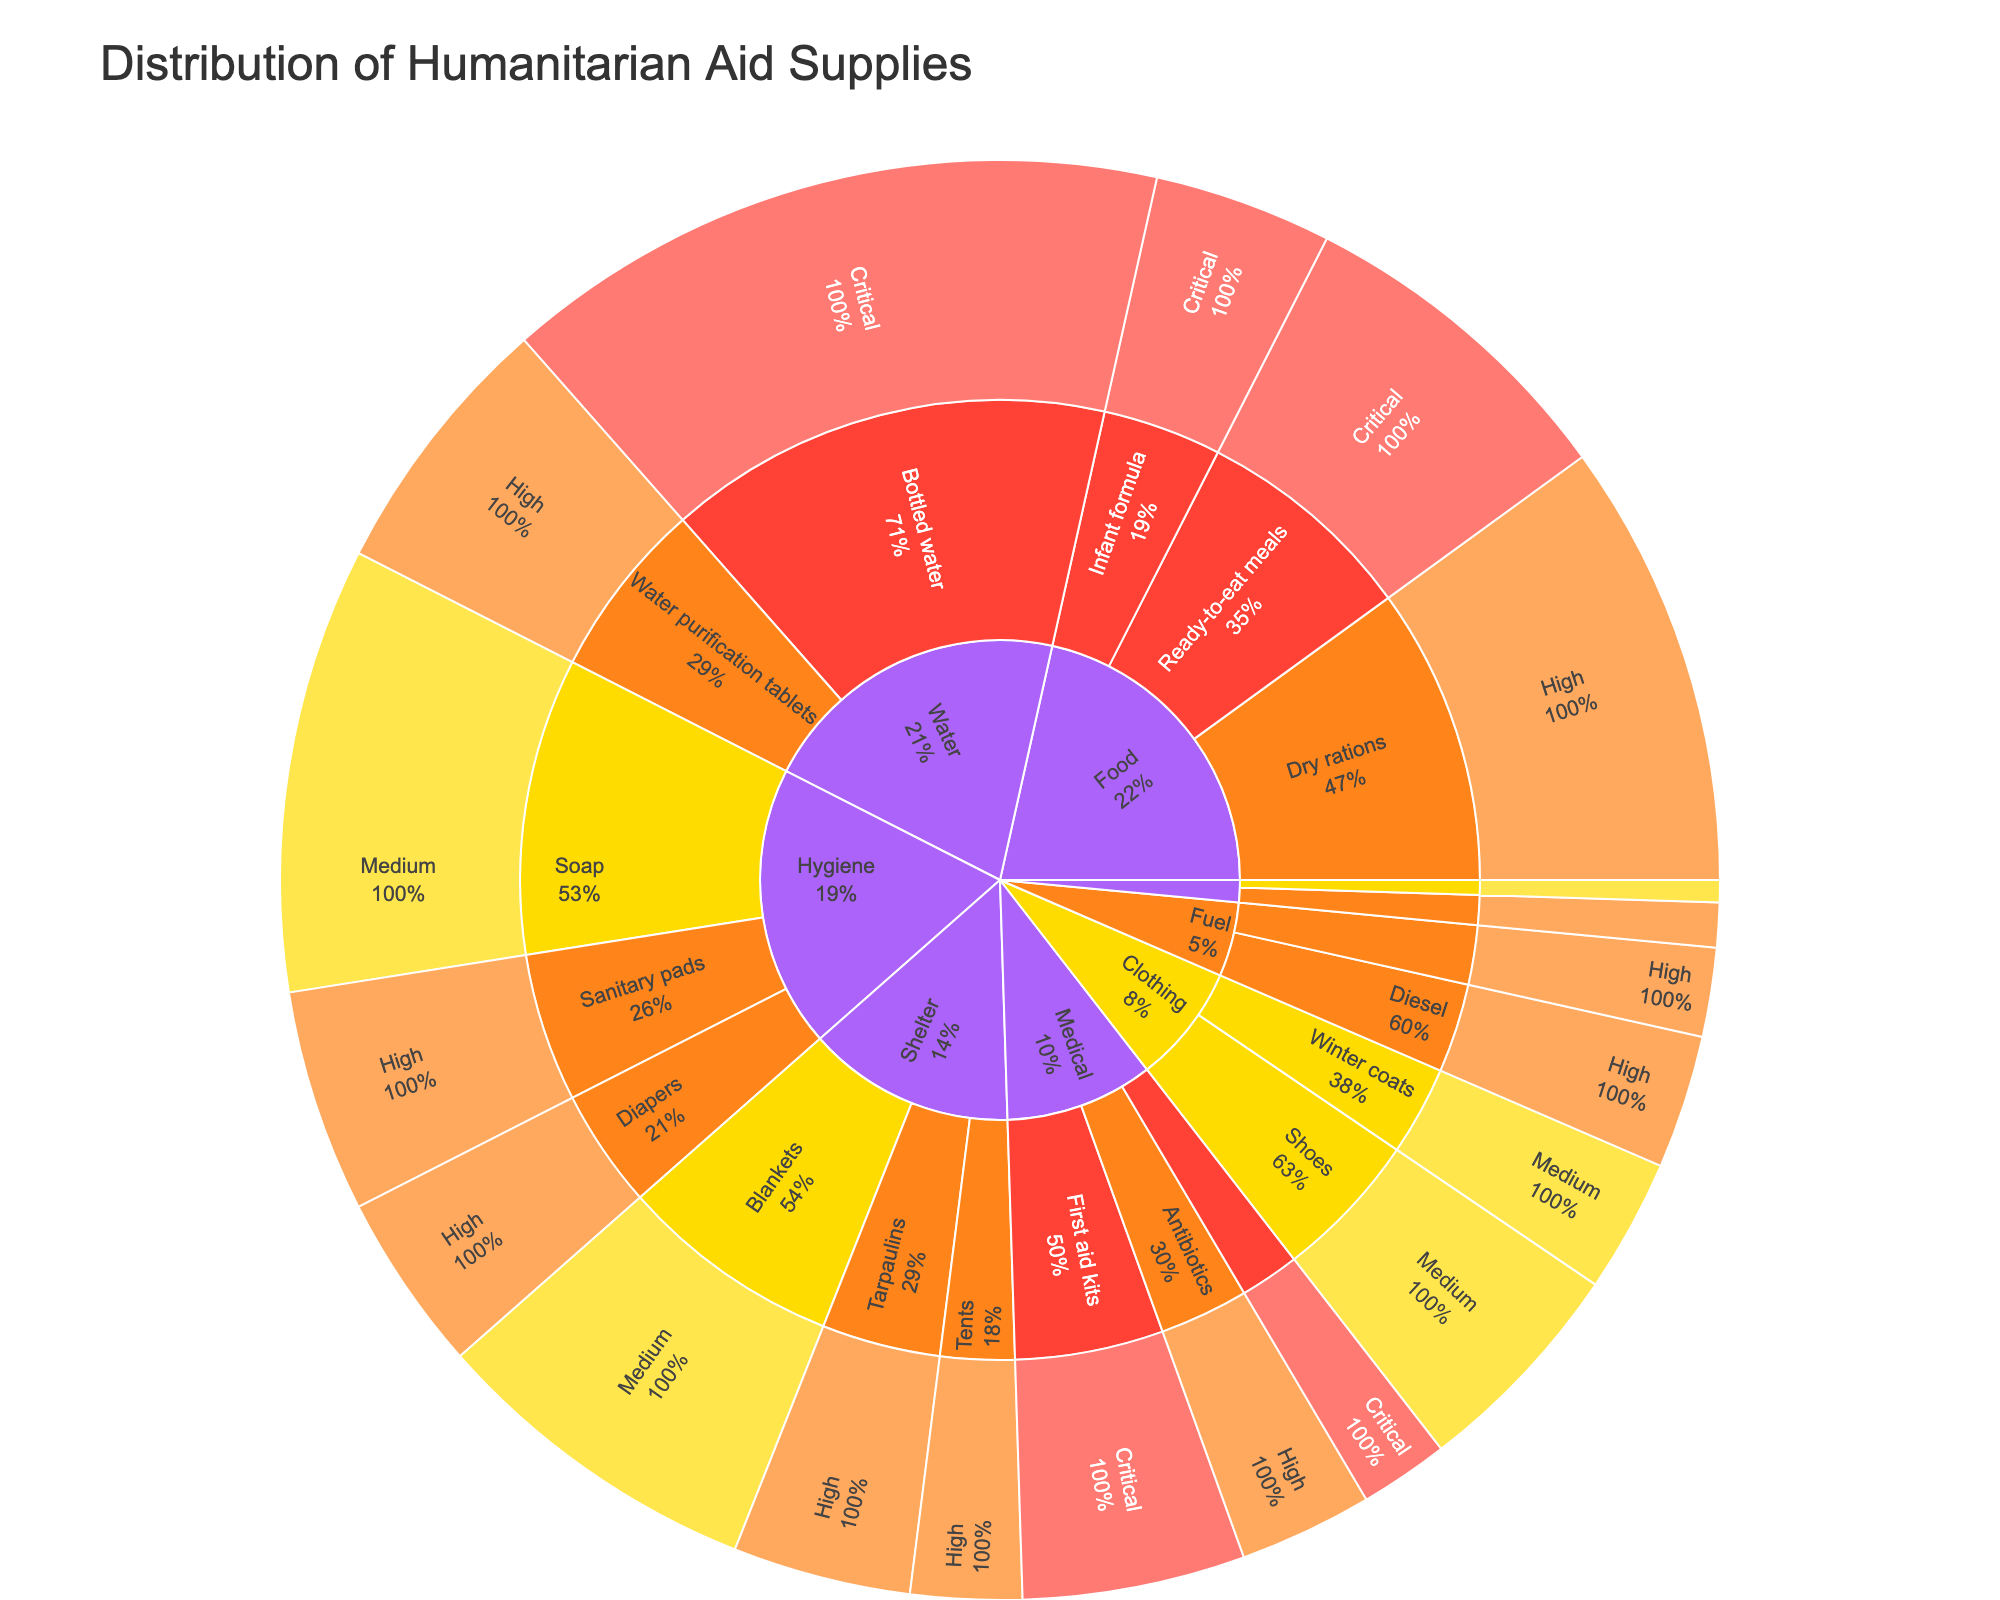What is the title of the plot? The title is usually located at the top of the plot and summarizes the content of the plot.
Answer: Distribution of Humanitarian Aid Supplies What category has the highest urgency level of Critical? Identify the outermost segment of the sunburst for Critical urgency and look for the primary category.
Answer: Food How many types of supplies are categorized under Shelter? Count the distinct segments within the Shelter category.
Answer: 3 What is the total value of Medical supplies marked as High urgency? Sum the values of Medical supplies with High urgency.
Answer: 600 Which category has the largest single value for supplies marked as Critical? Check the values within each category and subcategory for Critical urgency and identify the largest.
Answer: Water How does the value of Bottled water compare to the total value for all Hygiene supplies? First, find the value for Bottled water (3000). Then, sum up the values for all Hygiene supplies (Soap: 2000 + Sanitary pads: 1000 + Diapers: 800 = 3800). Compare these two values.
Answer: Bottled water is less than the total value for Hygiene supplies What percentage of the total Food supplies are Ready-to-eat meals? Calculate the total value for Food (1500 + 2000 + 800 = 4300). Then, find the percentage of Ready-to-eat meals (1500 / 4300).
Answer: Approximately 34.9% What is the relative size of the value for Winter coats compared to Shoes? Compare the values for Winter coats (600) and Shoes (1000) within the Clothing category.
Answer: Winter coats are 60% of Shoes Which category has the least number of items marked as Medium urgency? Count the Medium urgency segments under each category and identify the smallest count.
Answer: Communication Are there more High urgency items in Hygiene or Shelter? Count the High urgency segments and their values in both categories. Hygiene (Sanitary pads: 1000, Diapers: 800) and Shelter (Tents: 500, Tarpaulins: 800). Compare totals.
Answer: Hygiene 